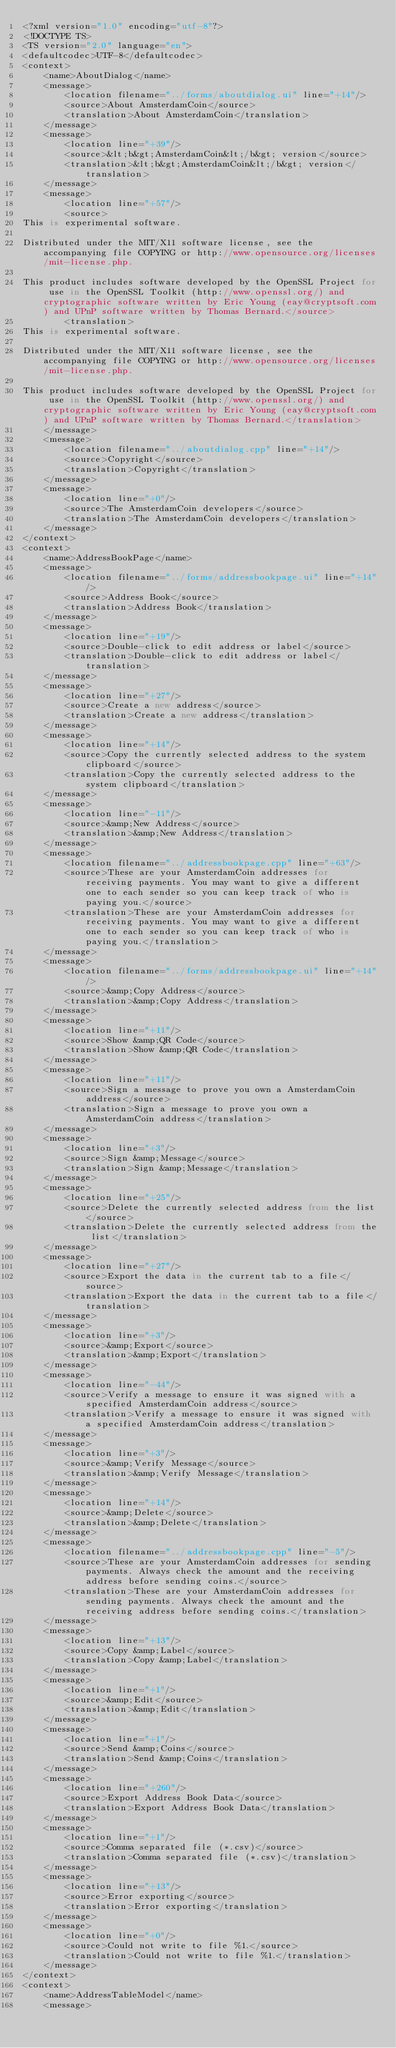<code> <loc_0><loc_0><loc_500><loc_500><_TypeScript_><?xml version="1.0" encoding="utf-8"?>
<!DOCTYPE TS>
<TS version="2.0" language="en">
<defaultcodec>UTF-8</defaultcodec>
<context>
    <name>AboutDialog</name>
    <message>
        <location filename="../forms/aboutdialog.ui" line="+14"/>
        <source>About AmsterdamCoin</source>
        <translation>About AmsterdamCoin</translation>
    </message>
    <message>
        <location line="+39"/>
        <source>&lt;b&gt;AmsterdamCoin&lt;/b&gt; version</source>
        <translation>&lt;b&gt;AmsterdamCoin&lt;/b&gt; version</translation>
    </message>
    <message>
        <location line="+57"/>
        <source>
This is experimental software.

Distributed under the MIT/X11 software license, see the accompanying file COPYING or http://www.opensource.org/licenses/mit-license.php.

This product includes software developed by the OpenSSL Project for use in the OpenSSL Toolkit (http://www.openssl.org/) and cryptographic software written by Eric Young (eay@cryptsoft.com) and UPnP software written by Thomas Bernard.</source>
        <translation>
This is experimental software.

Distributed under the MIT/X11 software license, see the accompanying file COPYING or http://www.opensource.org/licenses/mit-license.php.

This product includes software developed by the OpenSSL Project for use in the OpenSSL Toolkit (http://www.openssl.org/) and cryptographic software written by Eric Young (eay@cryptsoft.com) and UPnP software written by Thomas Bernard.</translation>
    </message>
    <message>
        <location filename="../aboutdialog.cpp" line="+14"/>
        <source>Copyright</source>
        <translation>Copyright</translation>
    </message>
    <message>
        <location line="+0"/>
        <source>The AmsterdamCoin developers</source>
        <translation>The AmsterdamCoin developers</translation>
    </message>
</context>
<context>
    <name>AddressBookPage</name>
    <message>
        <location filename="../forms/addressbookpage.ui" line="+14"/>
        <source>Address Book</source>
        <translation>Address Book</translation>
    </message>
    <message>
        <location line="+19"/>
        <source>Double-click to edit address or label</source>
        <translation>Double-click to edit address or label</translation>
    </message>
    <message>
        <location line="+27"/>
        <source>Create a new address</source>
        <translation>Create a new address</translation>
    </message>
    <message>
        <location line="+14"/>
        <source>Copy the currently selected address to the system clipboard</source>
        <translation>Copy the currently selected address to the system clipboard</translation>
    </message>
    <message>
        <location line="-11"/>
        <source>&amp;New Address</source>
        <translation>&amp;New Address</translation>
    </message>
    <message>
        <location filename="../addressbookpage.cpp" line="+63"/>
        <source>These are your AmsterdamCoin addresses for receiving payments. You may want to give a different one to each sender so you can keep track of who is paying you.</source>
        <translation>These are your AmsterdamCoin addresses for receiving payments. You may want to give a different one to each sender so you can keep track of who is paying you.</translation>
    </message>
    <message>
        <location filename="../forms/addressbookpage.ui" line="+14"/>
        <source>&amp;Copy Address</source>
        <translation>&amp;Copy Address</translation>
    </message>
    <message>
        <location line="+11"/>
        <source>Show &amp;QR Code</source>
        <translation>Show &amp;QR Code</translation>
    </message>
    <message>
        <location line="+11"/>
        <source>Sign a message to prove you own a AmsterdamCoin address</source>
        <translation>Sign a message to prove you own a AmsterdamCoin address</translation>
    </message>
    <message>
        <location line="+3"/>
        <source>Sign &amp;Message</source>
        <translation>Sign &amp;Message</translation>
    </message>
    <message>
        <location line="+25"/>
        <source>Delete the currently selected address from the list</source>
        <translation>Delete the currently selected address from the list</translation>
    </message>
    <message>
        <location line="+27"/>
        <source>Export the data in the current tab to a file</source>
        <translation>Export the data in the current tab to a file</translation>
    </message>
    <message>
        <location line="+3"/>
        <source>&amp;Export</source>
        <translation>&amp;Export</translation>
    </message>
    <message>
        <location line="-44"/>
        <source>Verify a message to ensure it was signed with a specified AmsterdamCoin address</source>
        <translation>Verify a message to ensure it was signed with a specified AmsterdamCoin address</translation>
    </message>
    <message>
        <location line="+3"/>
        <source>&amp;Verify Message</source>
        <translation>&amp;Verify Message</translation>
    </message>
    <message>
        <location line="+14"/>
        <source>&amp;Delete</source>
        <translation>&amp;Delete</translation>
    </message>
    <message>
        <location filename="../addressbookpage.cpp" line="-5"/>
        <source>These are your AmsterdamCoin addresses for sending payments. Always check the amount and the receiving address before sending coins.</source>
        <translation>These are your AmsterdamCoin addresses for sending payments. Always check the amount and the receiving address before sending coins.</translation>
    </message>
    <message>
        <location line="+13"/>
        <source>Copy &amp;Label</source>
        <translation>Copy &amp;Label</translation>
    </message>
    <message>
        <location line="+1"/>
        <source>&amp;Edit</source>
        <translation>&amp;Edit</translation>
    </message>
    <message>
        <location line="+1"/>
        <source>Send &amp;Coins</source>
        <translation>Send &amp;Coins</translation>
    </message>
    <message>
        <location line="+260"/>
        <source>Export Address Book Data</source>
        <translation>Export Address Book Data</translation>
    </message>
    <message>
        <location line="+1"/>
        <source>Comma separated file (*.csv)</source>
        <translation>Comma separated file (*.csv)</translation>
    </message>
    <message>
        <location line="+13"/>
        <source>Error exporting</source>
        <translation>Error exporting</translation>
    </message>
    <message>
        <location line="+0"/>
        <source>Could not write to file %1.</source>
        <translation>Could not write to file %1.</translation>
    </message>
</context>
<context>
    <name>AddressTableModel</name>
    <message></code> 